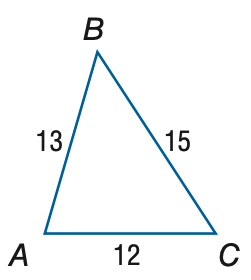Question: Find the measure of \angle A. Round to the nearest degree.
Choices:
A. 64
B. 69
C. 74
D. 79
Answer with the letter. Answer: C Question: Find the measure of \angle C. Round to the nearest degree.
Choices:
A. 51
B. 56
C. 61
D. 66
Answer with the letter. Answer: B 